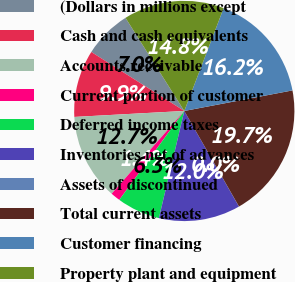<chart> <loc_0><loc_0><loc_500><loc_500><pie_chart><fcel>(Dollars in millions except<fcel>Cash and cash equivalents<fcel>Accounts receivable<fcel>Current portion of customer<fcel>Deferred income taxes<fcel>Inventories net of advances<fcel>Assets of discontinued<fcel>Total current assets<fcel>Customer financing<fcel>Property plant and equipment<nl><fcel>7.04%<fcel>9.86%<fcel>12.67%<fcel>1.42%<fcel>6.34%<fcel>11.97%<fcel>0.01%<fcel>19.71%<fcel>16.19%<fcel>14.78%<nl></chart> 